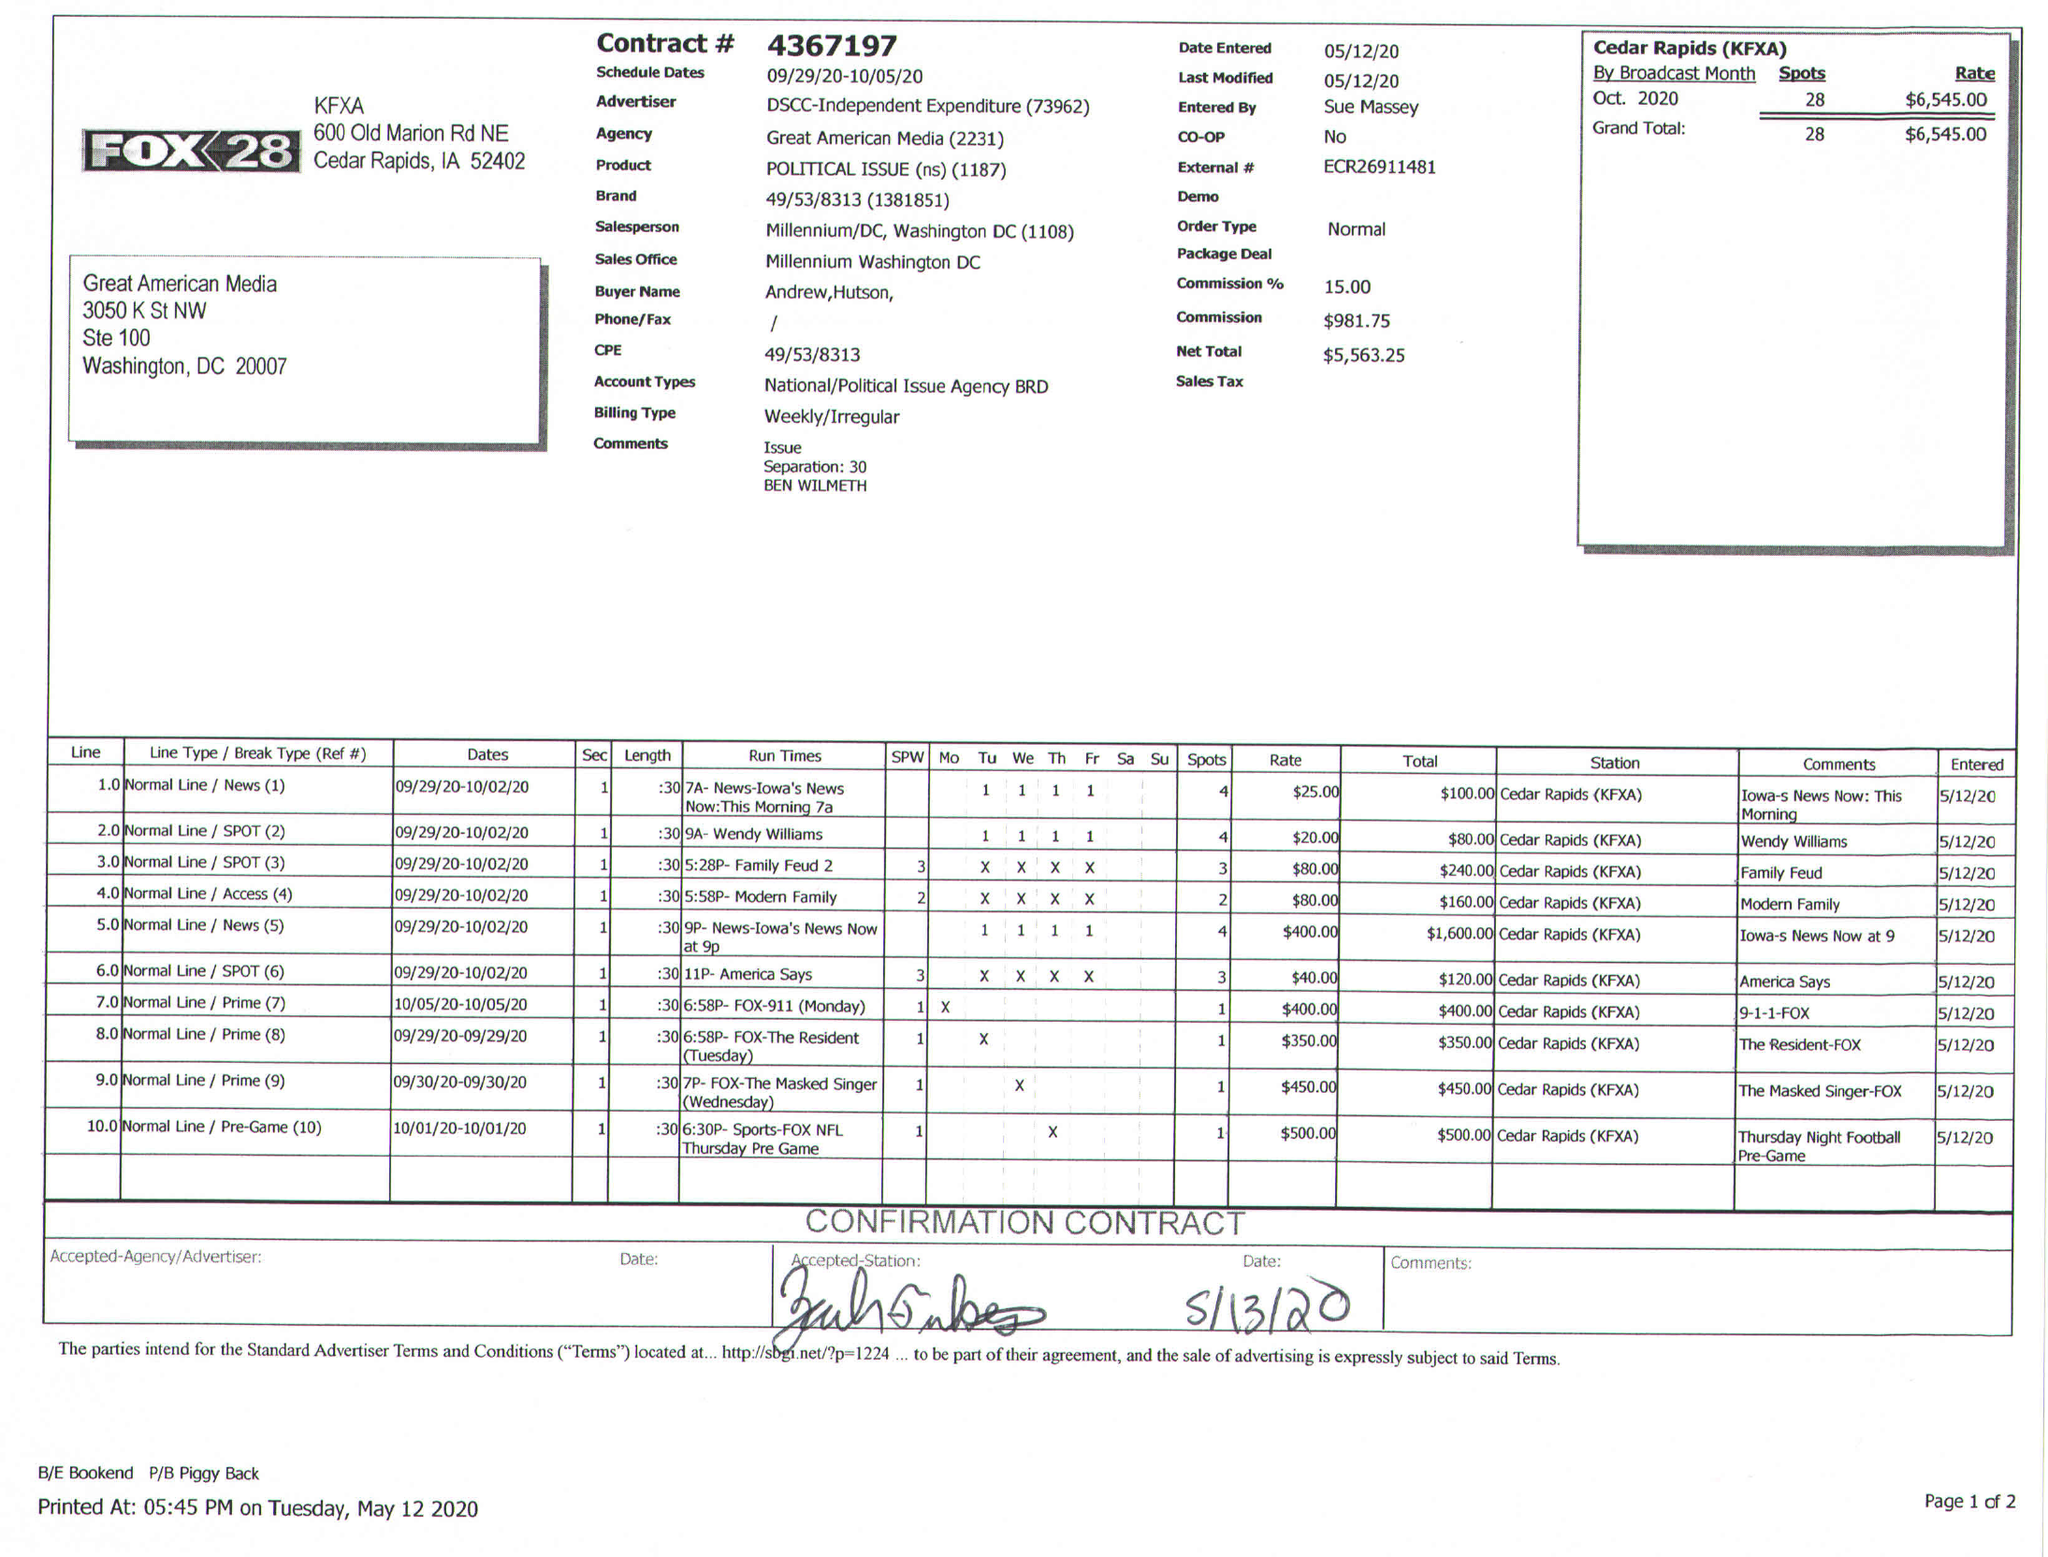What is the value for the flight_from?
Answer the question using a single word or phrase. 09/29/20 